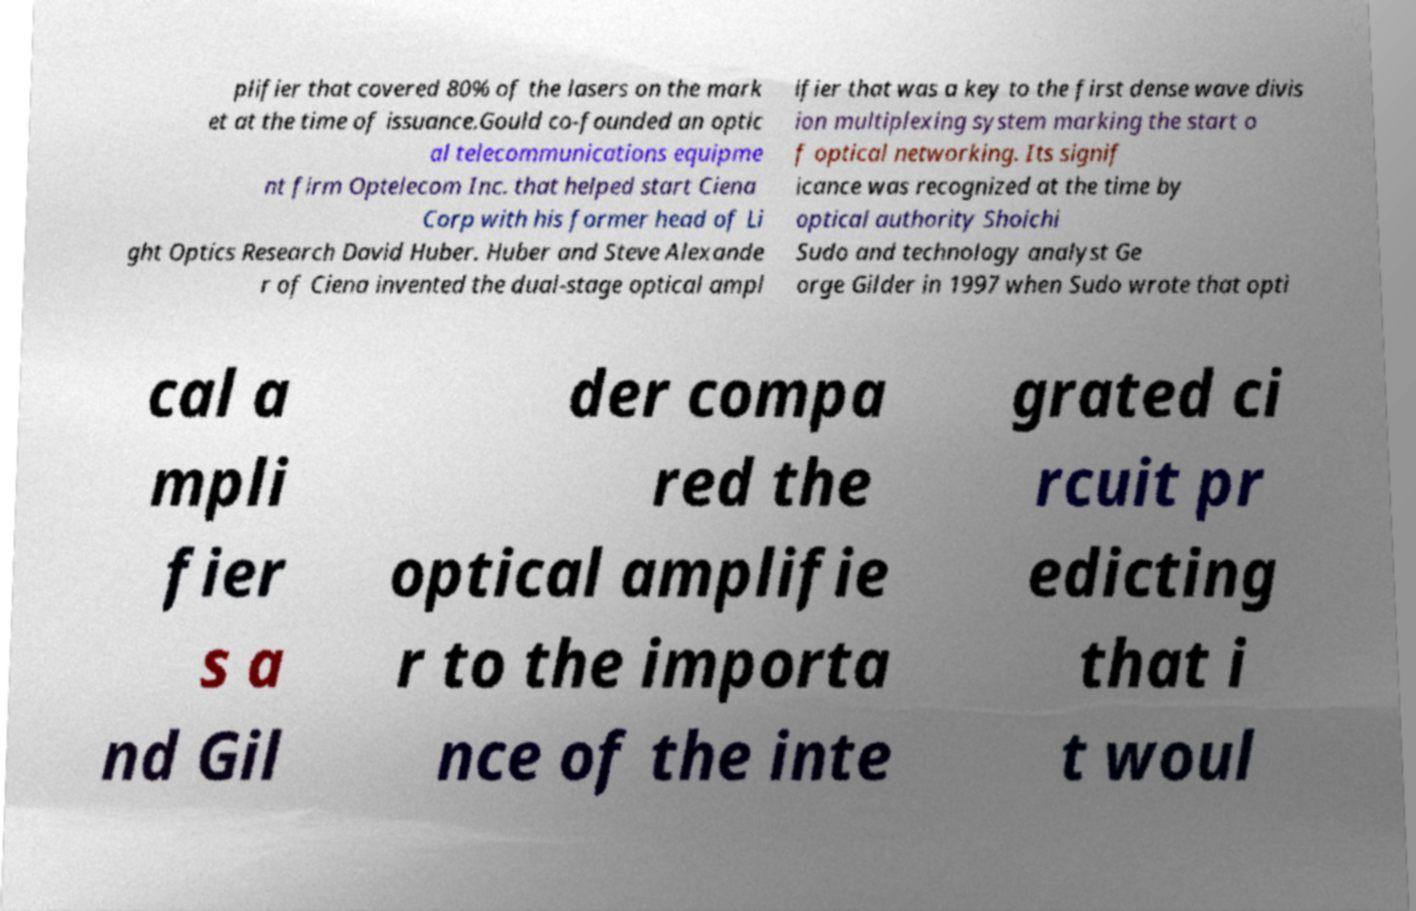Could you assist in decoding the text presented in this image and type it out clearly? plifier that covered 80% of the lasers on the mark et at the time of issuance.Gould co-founded an optic al telecommunications equipme nt firm Optelecom Inc. that helped start Ciena Corp with his former head of Li ght Optics Research David Huber. Huber and Steve Alexande r of Ciena invented the dual-stage optical ampl ifier that was a key to the first dense wave divis ion multiplexing system marking the start o f optical networking. Its signif icance was recognized at the time by optical authority Shoichi Sudo and technology analyst Ge orge Gilder in 1997 when Sudo wrote that opti cal a mpli fier s a nd Gil der compa red the optical amplifie r to the importa nce of the inte grated ci rcuit pr edicting that i t woul 